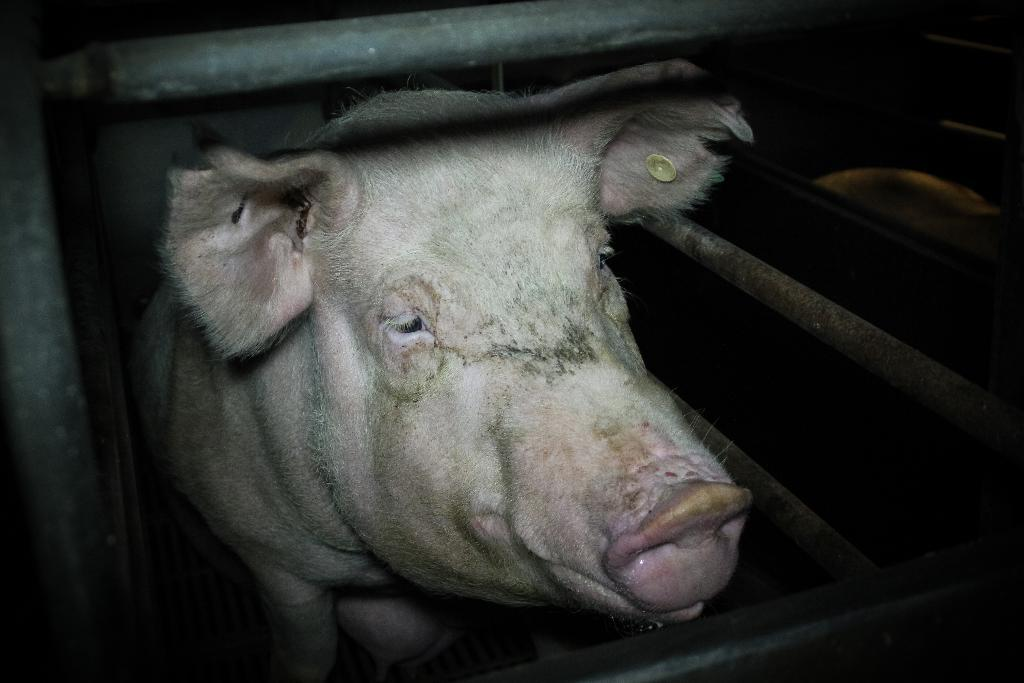What animal is present in the image? There is a pig in the image. Where is the pig located? The pig is in a box. What is the box made of? The box is made of metal. What else can be seen beside the box? There are two metal rods beside the box. What type of cabbage is being weighed on the scale in the image? There is no scale or cabbage present in the image; it features a pig in a metal box with two metal rods beside it. 